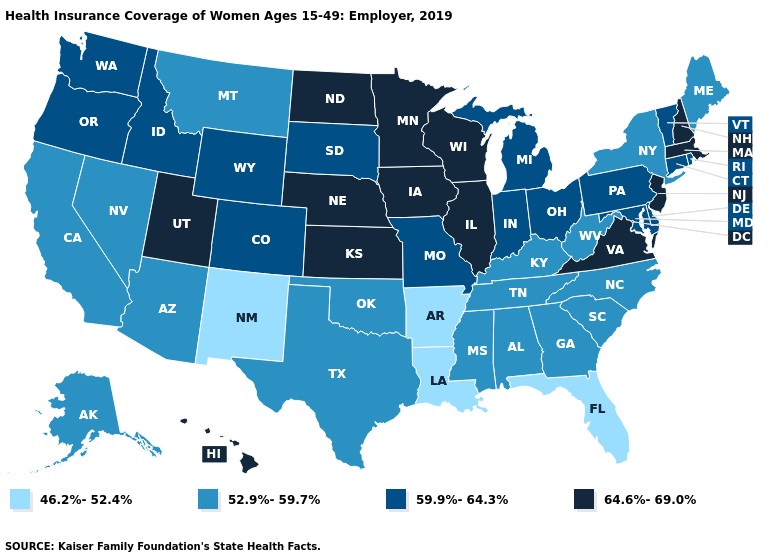Which states hav the highest value in the West?
Concise answer only. Hawaii, Utah. What is the value of Indiana?
Answer briefly. 59.9%-64.3%. Name the states that have a value in the range 46.2%-52.4%?
Short answer required. Arkansas, Florida, Louisiana, New Mexico. Does New Jersey have the highest value in the USA?
Give a very brief answer. Yes. What is the value of Iowa?
Answer briefly. 64.6%-69.0%. What is the value of Minnesota?
Quick response, please. 64.6%-69.0%. What is the value of South Carolina?
Keep it brief. 52.9%-59.7%. What is the value of Texas?
Keep it brief. 52.9%-59.7%. What is the value of Delaware?
Give a very brief answer. 59.9%-64.3%. Name the states that have a value in the range 59.9%-64.3%?
Short answer required. Colorado, Connecticut, Delaware, Idaho, Indiana, Maryland, Michigan, Missouri, Ohio, Oregon, Pennsylvania, Rhode Island, South Dakota, Vermont, Washington, Wyoming. Does Alaska have the same value as Minnesota?
Quick response, please. No. What is the highest value in the USA?
Answer briefly. 64.6%-69.0%. What is the value of Wisconsin?
Be succinct. 64.6%-69.0%. What is the value of West Virginia?
Short answer required. 52.9%-59.7%. Name the states that have a value in the range 52.9%-59.7%?
Be succinct. Alabama, Alaska, Arizona, California, Georgia, Kentucky, Maine, Mississippi, Montana, Nevada, New York, North Carolina, Oklahoma, South Carolina, Tennessee, Texas, West Virginia. 